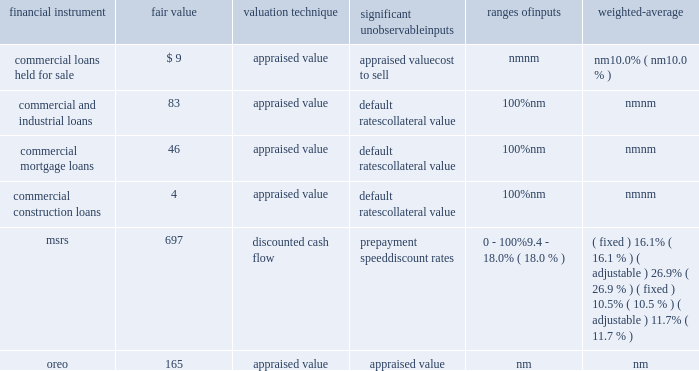Notes to consolidated financial statements 161 fifth third bancorp as of december 31 , 2012 ( $ in millions ) significant unobservable ranges of financial instrument fair value valuation technique inputs inputs weighted-average commercial loans held for sale $ 9 appraised value appraised value nm nm cost to sell nm 10.0% ( 10.0 % ) commercial and industrial loans 83 appraised value default rates 100% ( 100 % ) nm collateral value nm nm commercial mortgage loans 46 appraised value default rates 100% ( 100 % ) nm collateral value nm nm commercial construction loans 4 appraised value default rates 100% ( 100 % ) nm collateral value nm nm msrs 697 discounted cash flow prepayment speed 0 - 100% ( 100 % ) ( fixed ) 16.1% ( 16.1 % ) ( adjustable ) 26.9% ( 26.9 % ) discount rates 9.4 - 18.0% ( 18.0 % ) ( fixed ) 10.5% ( 10.5 % ) ( adjustable ) 11.7% ( 11.7 % ) .
Commercial loans held for sale during 2013 and 2012 , the bancorp transferred $ 5 million and $ 16 million , respectively , of commercial loans from the portfolio to loans held for sale that upon transfer were measured at fair value using significant unobservable inputs .
These loans had fair value adjustments in 2013 and 2012 totaling $ 4 million and $ 1 million , respectively , and were generally based on appraisals of the underlying collateral and were therefore , classified within level 3 of the valuation hierarchy .
Additionally , during 2013 and 2012 there were fair value adjustments on existing commercial loans held for sale of $ 3 million and $ 12 million , respectively .
The fair value adjustments were also based on appraisals of the underlying collateral and were therefore classified within level 3 of the valuation hierarchy .
An adverse change in the fair value of the underlying collateral would result in a decrease in the fair value measurement .
The accounting department determines the procedures for valuation of commercial hfs loans which may include a comparison to recently executed transactions of similar type loans .
A monthly review of the portfolio is performed for reasonableness .
Quarterly , appraisals approaching a year old are updated and the real estate valuation group , which reports to the chief risk and credit officer , in conjunction with the commercial line of business review the third party appraisals for reasonableness .
Additionally , the commercial line of business finance department , which reports to the bancorp chief financial officer , in conjunction with accounting review all loan appraisal values , carrying values and vintages .
Commercial loans held for investment during 2013 and 2012 , the bancorp recorded nonrecurring impairment adjustments to certain commercial and industrial , commercial mortgage and commercial construction loans held for investment .
Larger commercial loans included within aggregate borrower relationship balances exceeding $ 1 million that exhibit probable or observed credit weaknesses are subject to individual review for impairment .
The bancorp considers the current value of collateral , credit quality of any guarantees , the guarantor 2019s liquidity and willingness to cooperate , the loan structure and other factors when evaluating whether an individual loan is impaired .
When the loan is collateral dependent , the fair value of the loan is generally based on the fair value of the underlying collateral supporting the loan and therefore these loans were classified within level 3 of the valuation hierarchy .
In cases where the carrying value exceeds the fair value , an impairment loss is recognized .
An adverse change in the fair value of the underlying collateral would result in a decrease in the fair value measurement .
The fair values and recognized impairment losses are reflected in the previous table .
Commercial credit risk , which reports to the chief risk and credit officer , is responsible for preparing and reviewing the fair value estimates for commercial loans held for investment .
Mortgage interest rates increased during the year ended december 31 , 2013 and the bancorp recognized a recovery of temporary impairment on servicing rights .
The bancorp recognized temporary impairments in certain classes of the msr portfolio during the year ended december 31 , 2012 and the carrying value was adjusted to the fair value .
Msrs do not trade in an active , open market with readily observable prices .
While sales of msrs do occur , the precise terms and conditions typically are not readily available .
Accordingly , the bancorp estimates the fair value of msrs using internal discounted cash flow models with certain unobservable inputs , primarily prepayment speed assumptions , discount rates and weighted average lives , resulting in a classification within level 3 of the valuation hierarchy .
Refer to note 11 for further information on the assumptions used in the valuation of the bancorp 2019s msrs .
The secondary marketing department and treasury department are responsible for determining the valuation methodology for msrs .
Representatives from secondary marketing , treasury , accounting and risk management are responsible for reviewing key assumptions used in the internal discounted cash flow model .
Two external valuations of the msr portfolio are obtained from third parties that use valuation models in order to assess the reasonableness of the internal discounted cash flow model .
Additionally , the bancorp participates in peer surveys that provide additional confirmation of the reasonableness of key assumptions utilized in the msr valuation process and the resulting msr prices .
During 2013 and 2012 , the bancorp recorded nonrecurring adjustments to certain commercial and residential real estate properties classified as oreo and measured at the lower of carrying amount or fair value .
These nonrecurring losses are primarily due to declines in real estate values of the properties recorded in oreo .
For the years ended december 31 , 2013 and 2012 , these losses include $ 19 million and $ 17 million , respectively , recorded as charge-offs , on new oreo properties transferred from loans during the respective periods and $ 26 million and $ 57 million , respectively , recorded as negative fair value adjustments on oreo in other noninterest income subsequent to their transfer from loans .
As discussed in the following paragraphs , the fair value amounts are generally based on appraisals of the property values , resulting in a .
During 2013 , were the fair value adjustments greater for loans transferred to held for sale greater than the adjustments for loans already classified as held for sale? 
Computations: (5 > 3)
Answer: yes. 